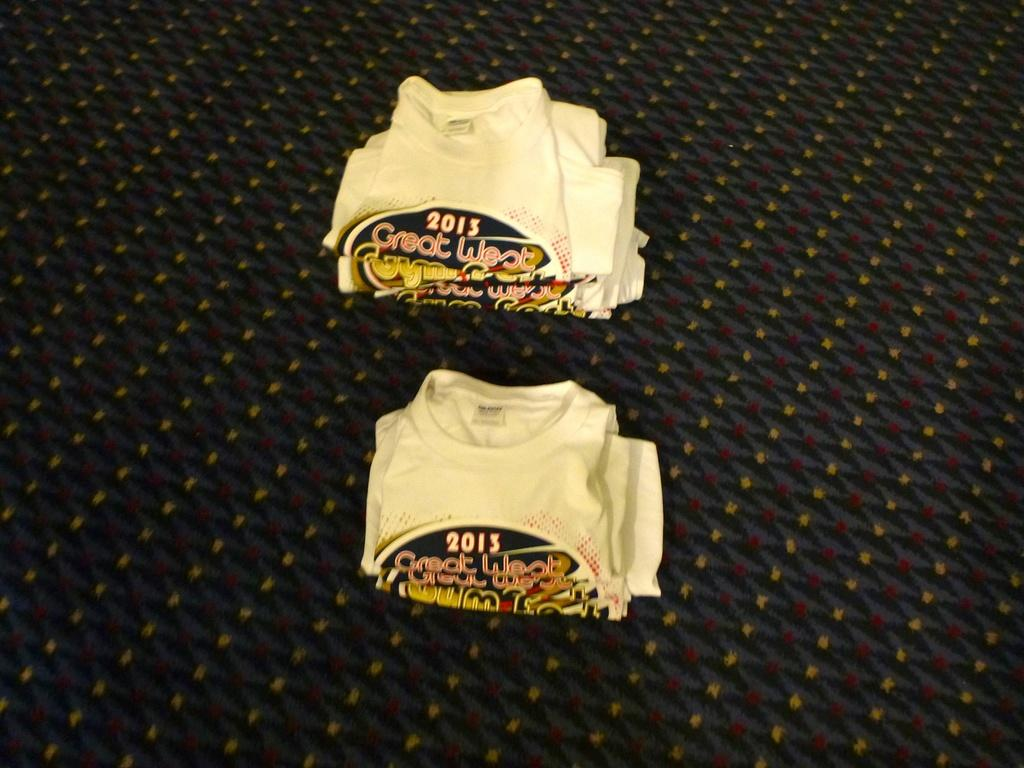<image>
Create a compact narrative representing the image presented. Several t-shirts from Great West 2013 sit folded on a carpeted floor. 